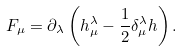Convert formula to latex. <formula><loc_0><loc_0><loc_500><loc_500>F _ { \mu } = \partial _ { \lambda } \left ( h _ { \mu } ^ { \lambda } - \frac { 1 } { 2 } \delta _ { \mu } ^ { \lambda } h \right ) .</formula> 